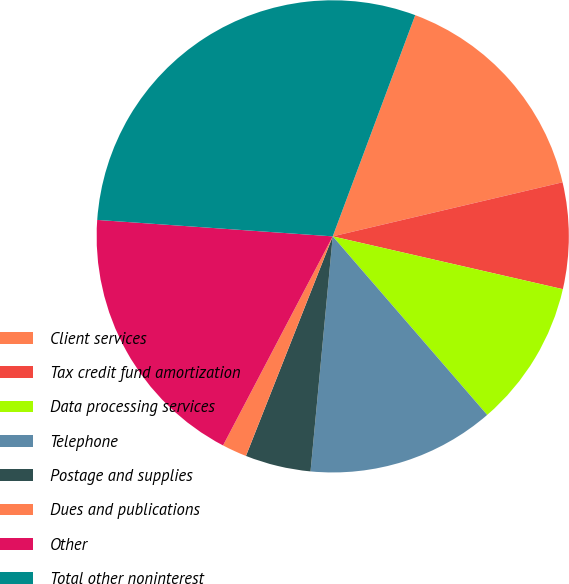<chart> <loc_0><loc_0><loc_500><loc_500><pie_chart><fcel>Client services<fcel>Tax credit fund amortization<fcel>Data processing services<fcel>Telephone<fcel>Postage and supplies<fcel>Dues and publications<fcel>Other<fcel>Total other noninterest<nl><fcel>15.64%<fcel>7.27%<fcel>10.06%<fcel>12.85%<fcel>4.49%<fcel>1.7%<fcel>18.42%<fcel>29.57%<nl></chart> 